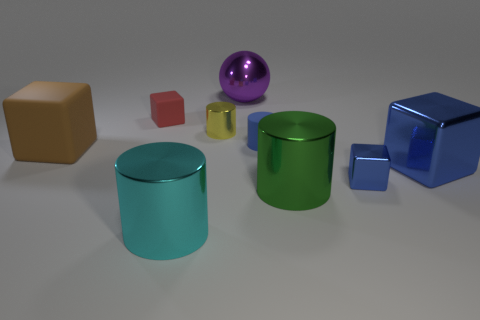Add 1 shiny things. How many objects exist? 10 Subtract all cubes. How many objects are left? 5 Subtract all small yellow shiny things. Subtract all purple objects. How many objects are left? 7 Add 6 yellow shiny cylinders. How many yellow shiny cylinders are left? 7 Add 7 large blue cylinders. How many large blue cylinders exist? 7 Subtract 1 yellow cylinders. How many objects are left? 8 